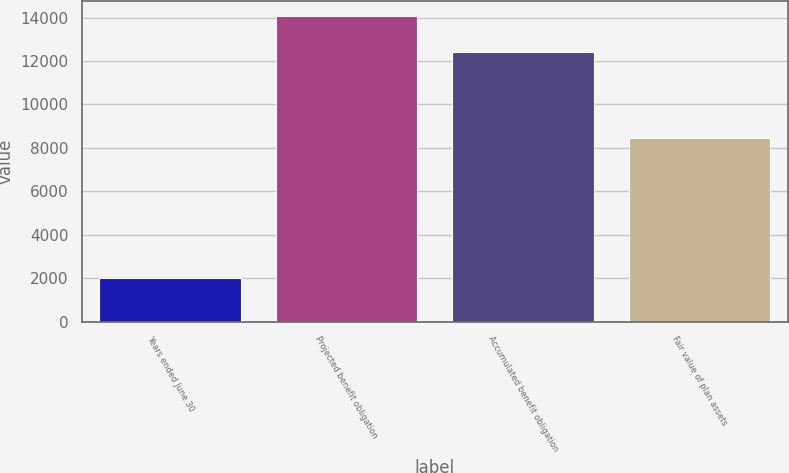Convert chart. <chart><loc_0><loc_0><loc_500><loc_500><bar_chart><fcel>Years ended June 30<fcel>Projected benefit obligation<fcel>Accumulated benefit obligation<fcel>Fair value of plan assets<nl><fcel>2015<fcel>14057<fcel>12419<fcel>8435<nl></chart> 